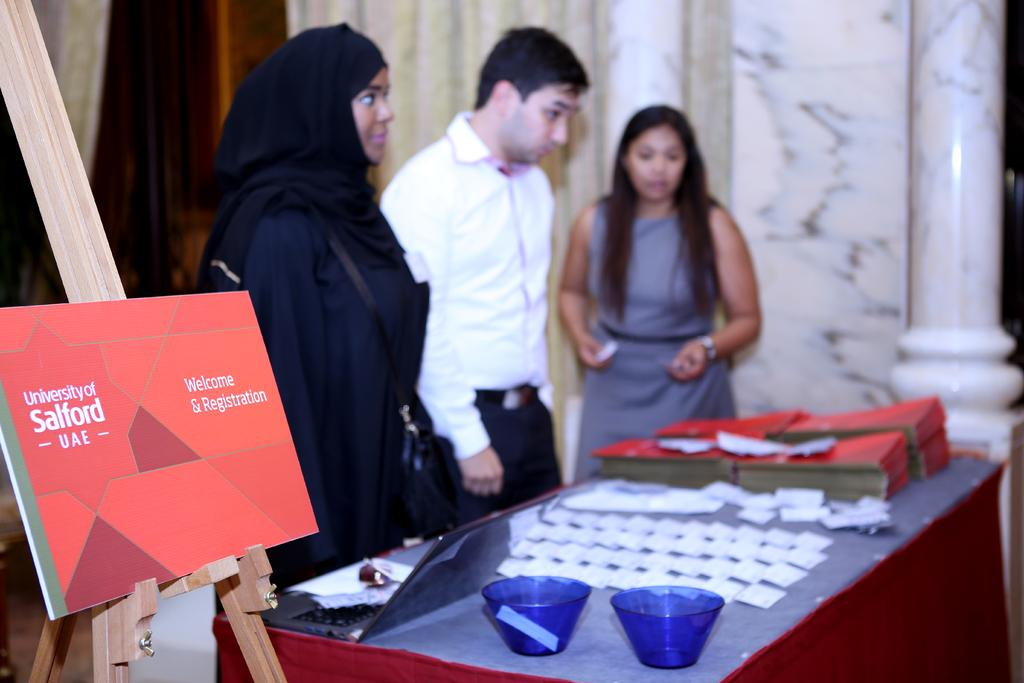How many people are in the image? There are three persons in the image. What is present on the table in the image? There are bowls, a laptop, papers, and books on the table in the image. What can be seen on the wall in the background of the image? There is a board on the wall in the background of the image. What architectural feature is visible in the background of the image? There is a pillar in the background of the image. What type of breakfast is being served on the table in the image? There is no breakfast visible in the image; the table contains bowls, a laptop, papers, and books. What is the name of the society that is meeting in the image? There is no indication of a society meeting in the image; it features three people, a table, and various objects. 